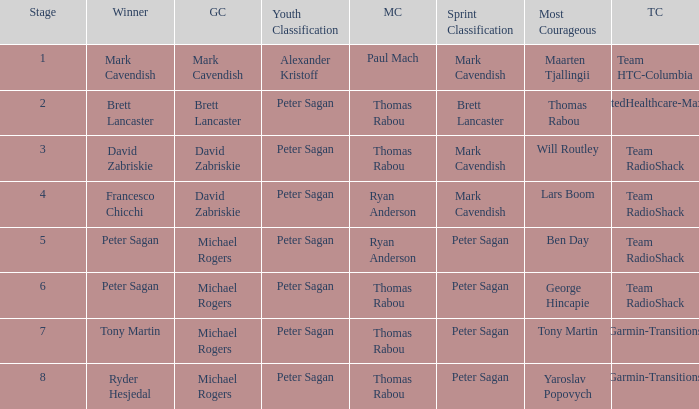Who won the mountains classification when Maarten Tjallingii won most corageous? Paul Mach. 